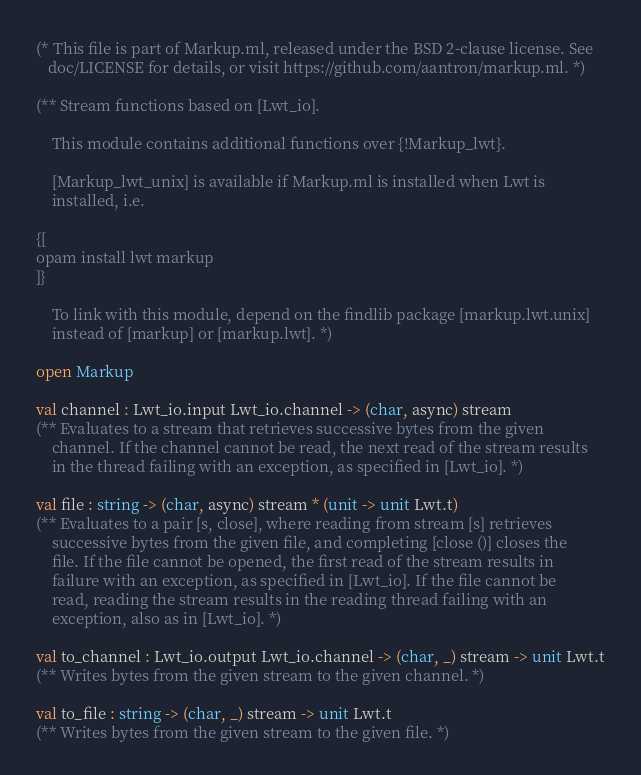Convert code to text. <code><loc_0><loc_0><loc_500><loc_500><_OCaml_>(* This file is part of Markup.ml, released under the BSD 2-clause license. See
   doc/LICENSE for details, or visit https://github.com/aantron/markup.ml. *)

(** Stream functions based on [Lwt_io].

    This module contains additional functions over {!Markup_lwt}.

    [Markup_lwt_unix] is available if Markup.ml is installed when Lwt is
    installed, i.e.

{[
opam install lwt markup
]}

    To link with this module, depend on the findlib package [markup.lwt.unix]
    instead of [markup] or [markup.lwt]. *)

open Markup

val channel : Lwt_io.input Lwt_io.channel -> (char, async) stream
(** Evaluates to a stream that retrieves successive bytes from the given
    channel. If the channel cannot be read, the next read of the stream results
    in the thread failing with an exception, as specified in [Lwt_io]. *)

val file : string -> (char, async) stream * (unit -> unit Lwt.t)
(** Evaluates to a pair [s, close], where reading from stream [s] retrieves
    successive bytes from the given file, and completing [close ()] closes the
    file. If the file cannot be opened, the first read of the stream results in
    failure with an exception, as specified in [Lwt_io]. If the file cannot be
    read, reading the stream results in the reading thread failing with an
    exception, also as in [Lwt_io]. *)

val to_channel : Lwt_io.output Lwt_io.channel -> (char, _) stream -> unit Lwt.t
(** Writes bytes from the given stream to the given channel. *)

val to_file : string -> (char, _) stream -> unit Lwt.t
(** Writes bytes from the given stream to the given file. *)
</code> 